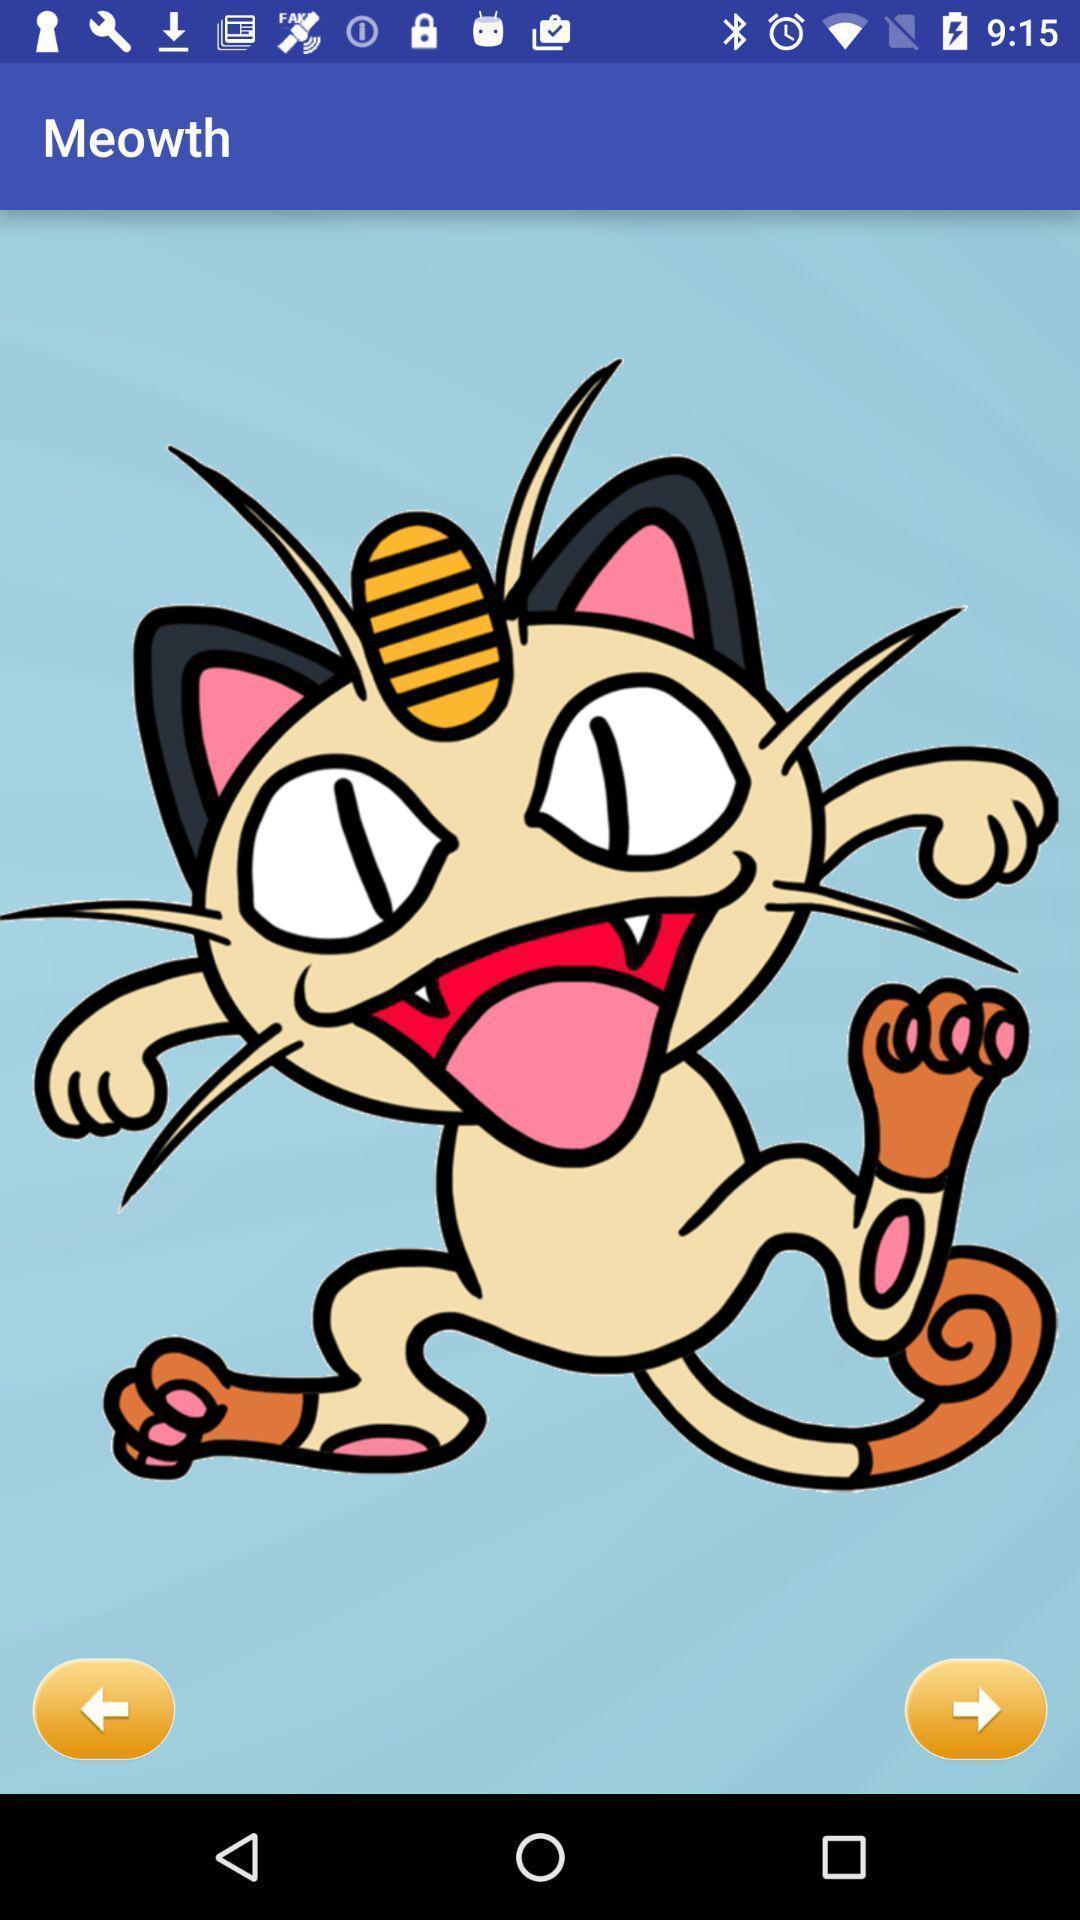Provide a detailed account of this screenshot. Screen showing an image. 